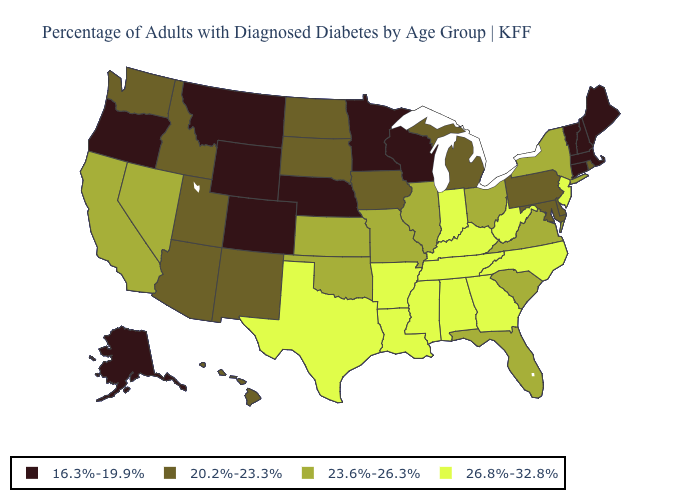Name the states that have a value in the range 26.8%-32.8%?
Write a very short answer. Alabama, Arkansas, Georgia, Indiana, Kentucky, Louisiana, Mississippi, New Jersey, North Carolina, Tennessee, Texas, West Virginia. What is the value of Missouri?
Give a very brief answer. 23.6%-26.3%. What is the highest value in the USA?
Be succinct. 26.8%-32.8%. Name the states that have a value in the range 16.3%-19.9%?
Write a very short answer. Alaska, Colorado, Connecticut, Maine, Massachusetts, Minnesota, Montana, Nebraska, New Hampshire, Oregon, Vermont, Wisconsin, Wyoming. Does North Carolina have the highest value in the USA?
Short answer required. Yes. Does Alaska have the lowest value in the West?
Give a very brief answer. Yes. Among the states that border Kentucky , which have the highest value?
Keep it brief. Indiana, Tennessee, West Virginia. Which states have the lowest value in the USA?
Be succinct. Alaska, Colorado, Connecticut, Maine, Massachusetts, Minnesota, Montana, Nebraska, New Hampshire, Oregon, Vermont, Wisconsin, Wyoming. Does Minnesota have the lowest value in the MidWest?
Be succinct. Yes. Is the legend a continuous bar?
Give a very brief answer. No. Among the states that border New Hampshire , which have the lowest value?
Be succinct. Maine, Massachusetts, Vermont. What is the value of Idaho?
Keep it brief. 20.2%-23.3%. What is the value of Nebraska?
Keep it brief. 16.3%-19.9%. What is the value of North Carolina?
Keep it brief. 26.8%-32.8%. What is the highest value in states that border California?
Answer briefly. 23.6%-26.3%. 